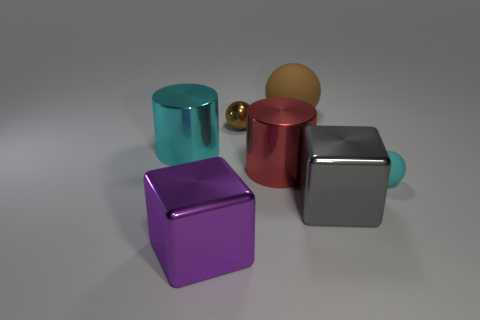Subtract all tiny cyan balls. How many balls are left? 2 Subtract 1 blocks. How many blocks are left? 1 Add 2 cubes. How many objects exist? 9 Subtract all cyan balls. How many balls are left? 2 Subtract all brown spheres. Subtract all gray cubes. How many spheres are left? 1 Subtract all cyan cylinders. How many gray blocks are left? 1 Subtract all small red rubber cubes. Subtract all purple cubes. How many objects are left? 6 Add 1 large metallic blocks. How many large metallic blocks are left? 3 Add 2 big brown objects. How many big brown objects exist? 3 Subtract 0 blue cubes. How many objects are left? 7 